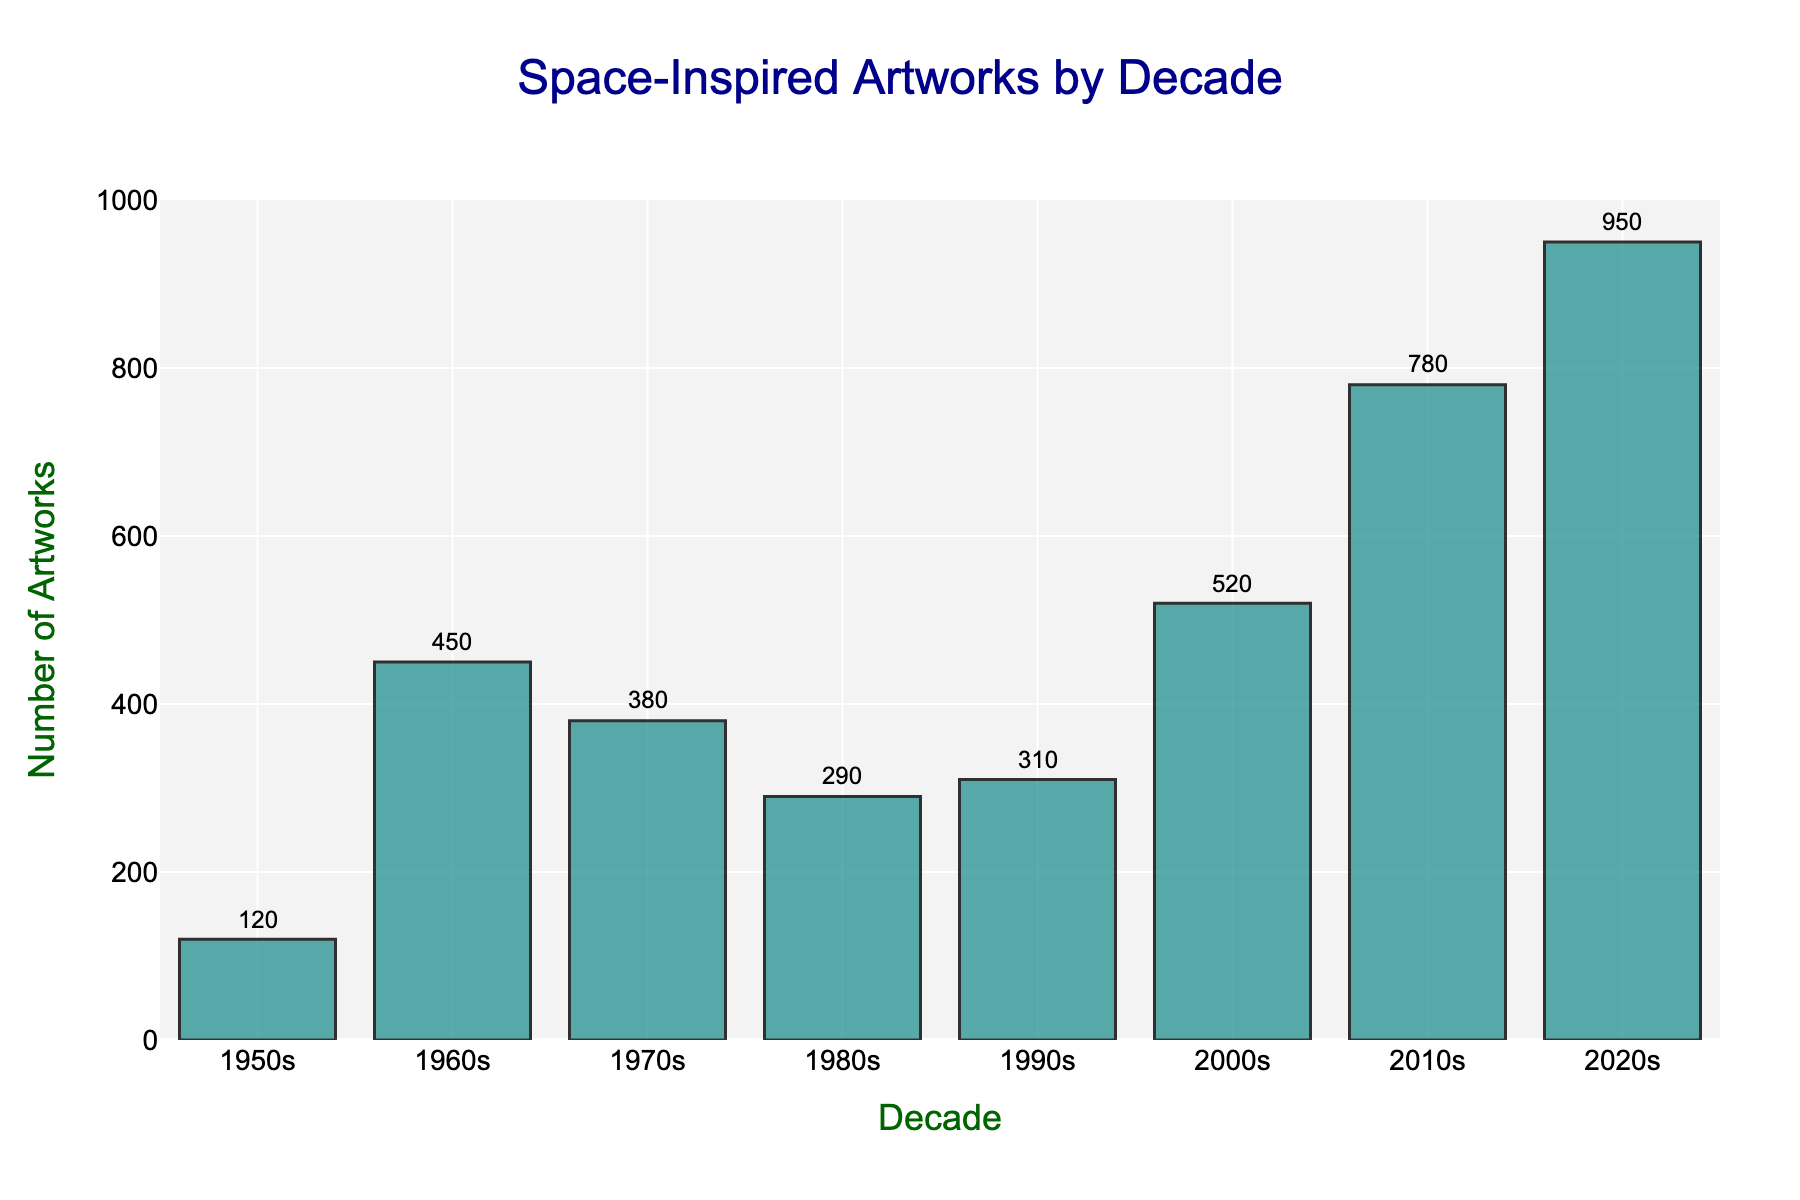What's the title of the figure? The title is usually prominently displayed at the top of the figure. From the code provided, the title is 'Space-Inspired Artworks by Decade'.
Answer: Space-Inspired Artworks by Decade Which decade had the highest number of space-inspired artworks created? Looking at the heights of the bars, the 2020s have the tallest bar, indicating the highest number of artworks. Thus, the 2020s had the highest number of space-inspired artworks created.
Answer: 2020s How many space-inspired artworks were created in the 2000s? Referring to the bar corresponding to the 2000s, the figure annotated at the top of this bar is 520.
Answer: 520 What is the difference in the number of space-inspired artworks between the 1960s and the 1970s? To find the difference, subtract the number of artworks in the 1970s from that in the 1960s. 450 (1960s) - 380 (1970s) = 70.
Answer: 70 Which decades had fewer than 300 space-inspired artworks created? Checking the height of the bars, only the 1950s and 1980s have values below 300.
Answer: 1950s, 1980s How does the number of space-inspired artworks in the 1980s compare to those in the 1990s? Observe the heights of the bars for the 1980s and the 1990s. The 1990s have a slightly higher bar (310) compared to the 1980s (290). Thus, the 1990s had more artworks.
Answer: 1990s had more What is the average number of space-inspired artworks per decade from the 1950s to the 2020s? Sum the number of artworks from all decades and divide by the number of decades. (120 + 450 + 380 + 290 + 310 + 520 + 780 + 950) / 8 = 3800 / 8 = 475.
Answer: 475 What is the increase in the number of space-inspired artworks from the 2000s to the 2020s? Subtract the number of artworks in the 2000s from those in the 2020s. 950 (2020s) - 520 (2000s) = 430.
Answer: 430 Which decade had the lowest number of space-inspired artworks? The 1950s had the shortest bar, representing the lowest number of artworks, which is 120.
Answer: 1950s By how much did the number of space-inspired artworks increase from the 1950s to the 1960s? Subtract the number of artworks in the 1950s from those in the 1960s. 450 (1960s) - 120 (1950s) = 330.
Answer: 330 